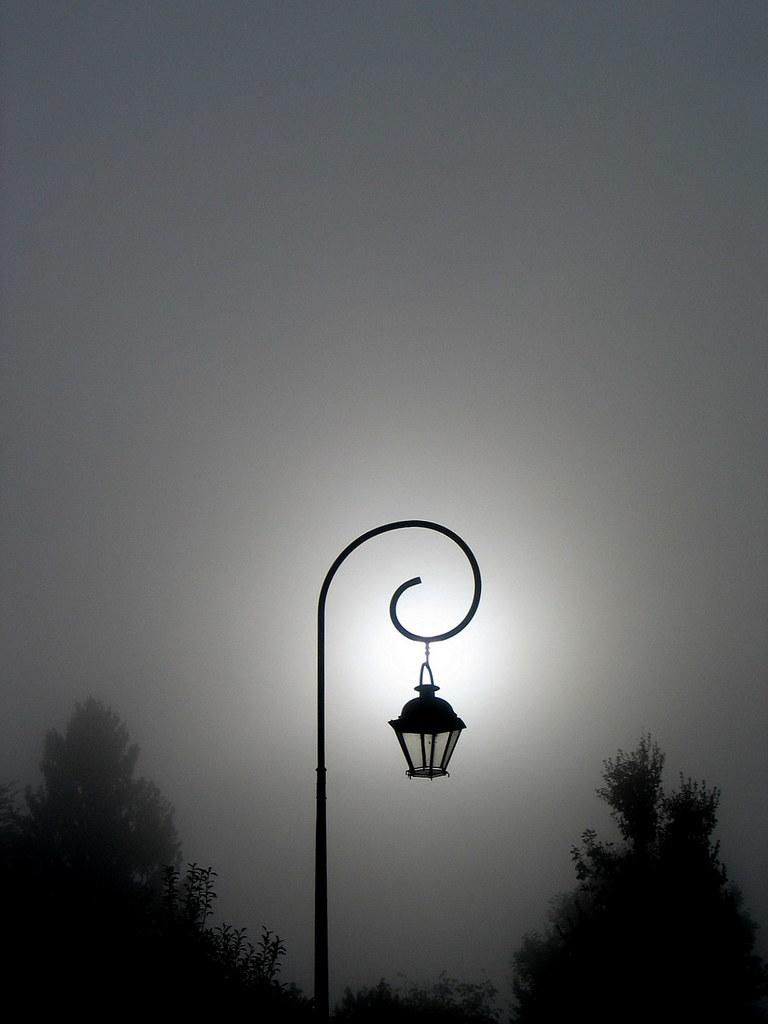What is the main object in the middle of the image? There is a pole in the middle of the image. What is attached to the pole? There is a light on the pole. What can be seen in the background of the image? There are trees in the background of the image. What is visible at the top of the image? The sky is visible at the top of the image. What type of rhythm can be heard coming from the pole in the image? There is no sound or rhythm associated with the pole in the image. 